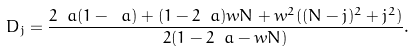<formula> <loc_0><loc_0><loc_500><loc_500>D _ { j } = \frac { 2 \ a ( 1 - \ a ) + ( 1 - 2 \ a ) w N + w ^ { 2 } ( ( N - j ) ^ { 2 } + j ^ { 2 } ) } { 2 ( 1 - 2 \ a - w N ) } .</formula> 